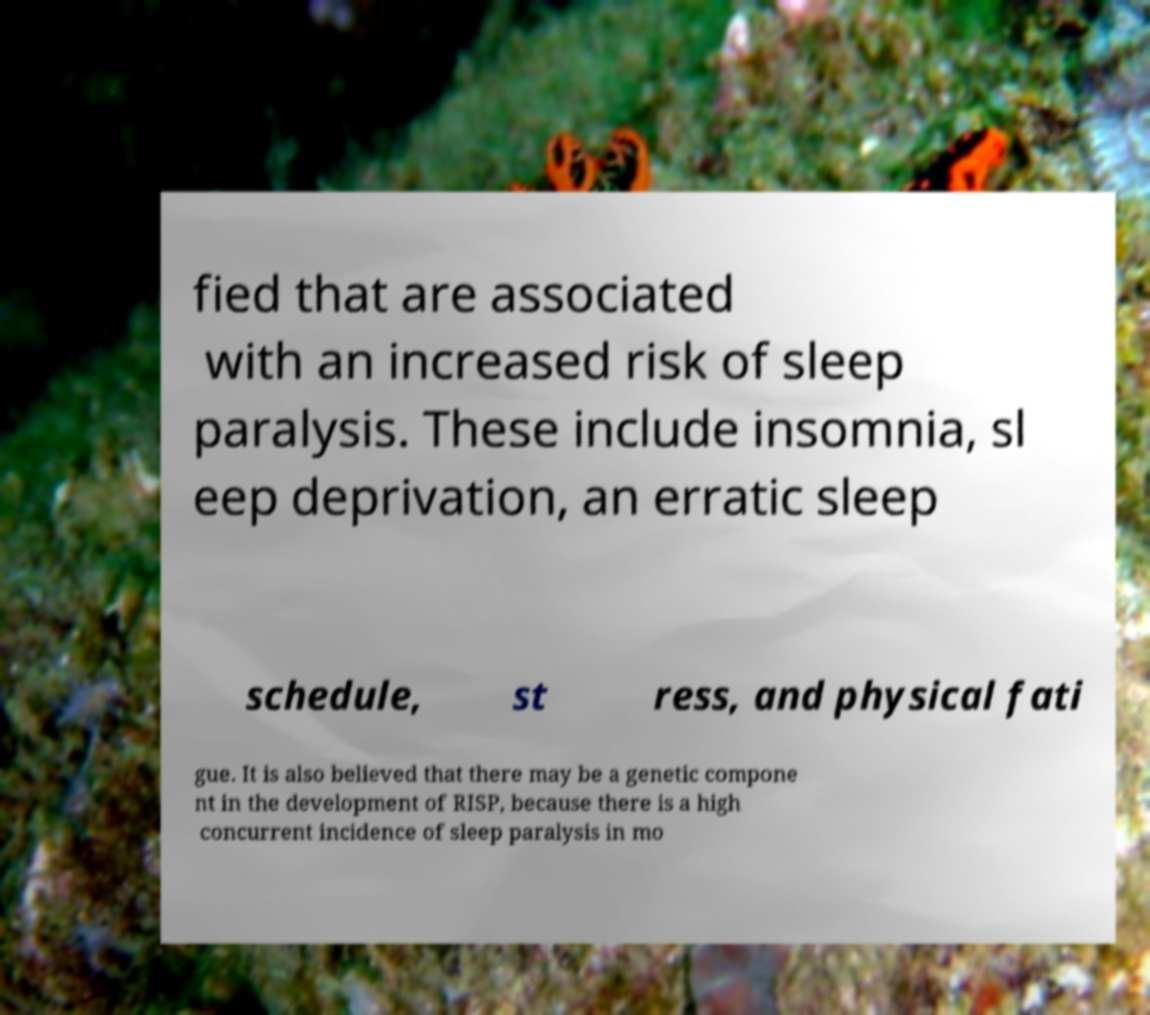Please read and relay the text visible in this image. What does it say? fied that are associated with an increased risk of sleep paralysis. These include insomnia, sl eep deprivation, an erratic sleep schedule, st ress, and physical fati gue. It is also believed that there may be a genetic compone nt in the development of RISP, because there is a high concurrent incidence of sleep paralysis in mo 